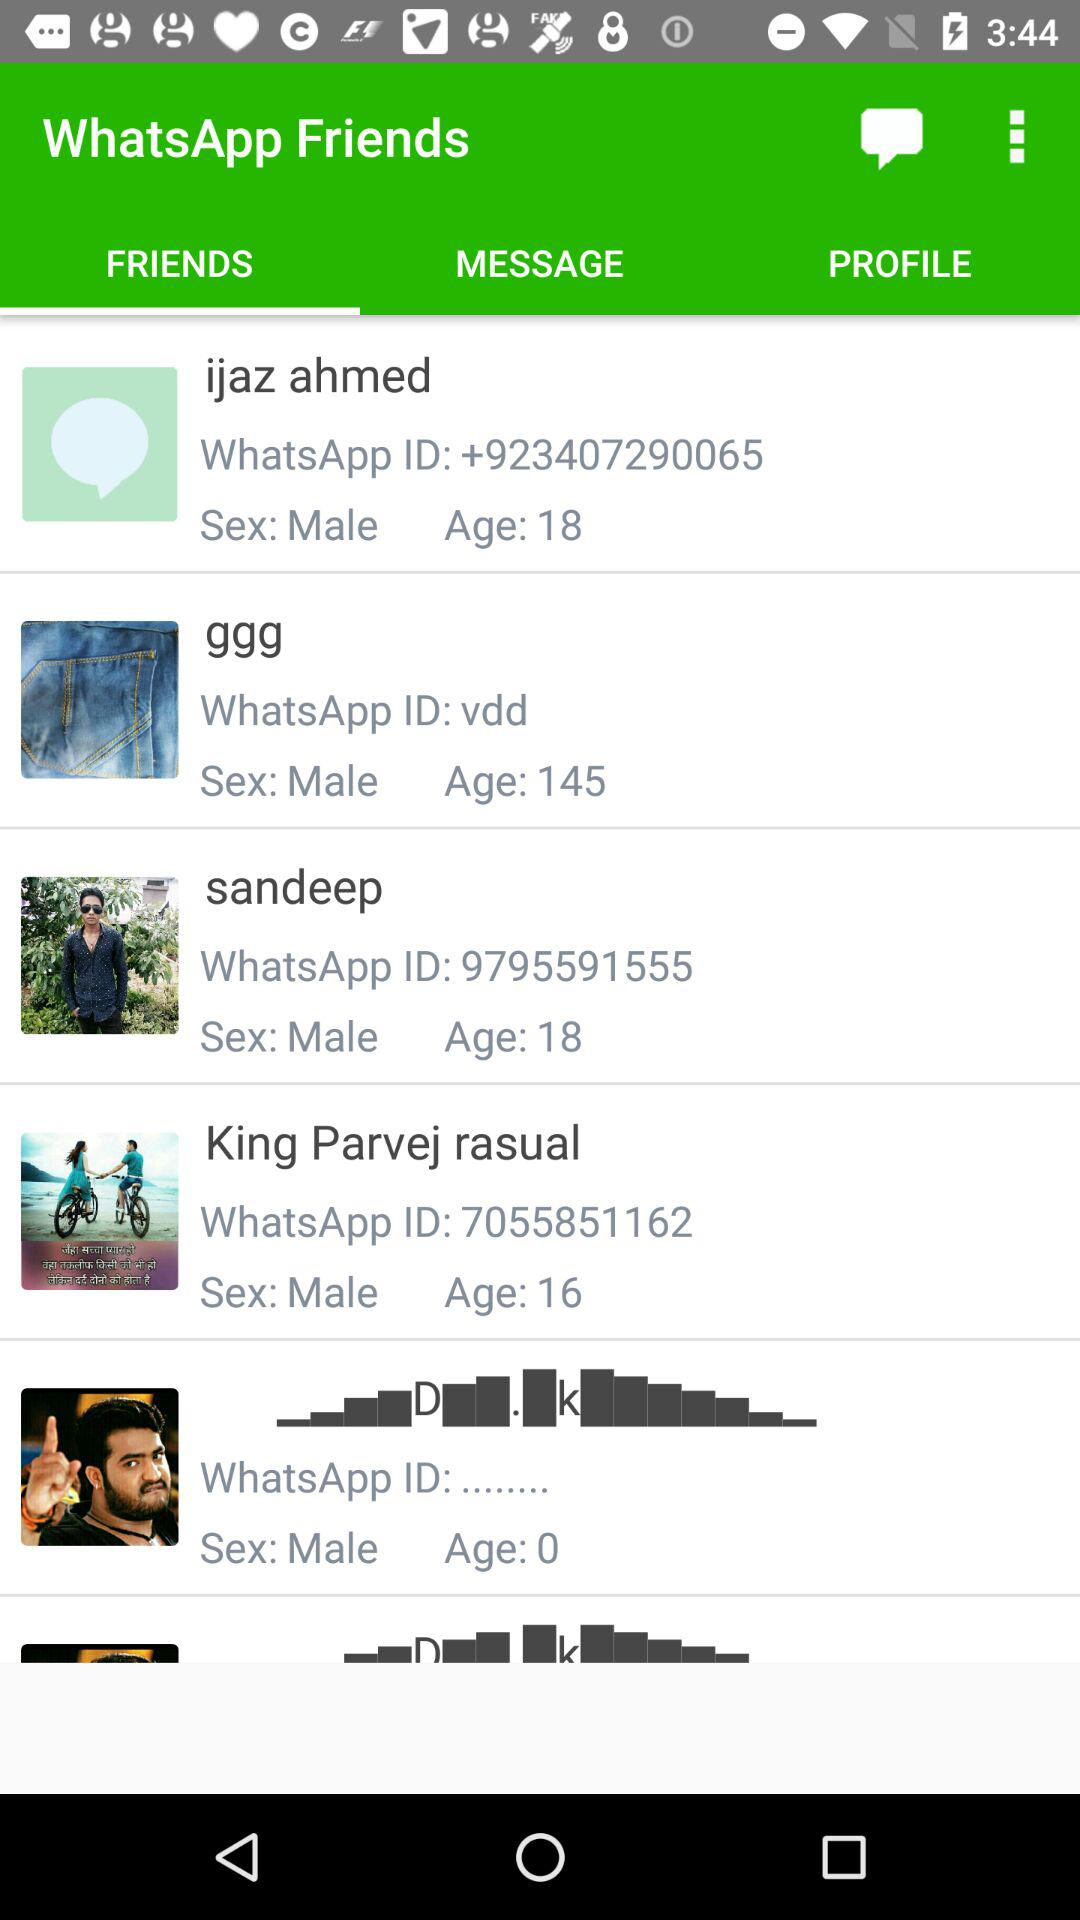Which person is 16 years old? The person is King Parvej Rasual. 